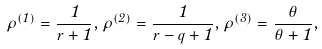Convert formula to latex. <formula><loc_0><loc_0><loc_500><loc_500>\rho ^ { ( 1 ) } = \frac { 1 } { r + 1 } , \rho ^ { ( 2 ) } = \frac { 1 } { r - q + 1 } , \rho ^ { ( 3 ) } = \frac { \theta } { \theta + 1 } ,</formula> 